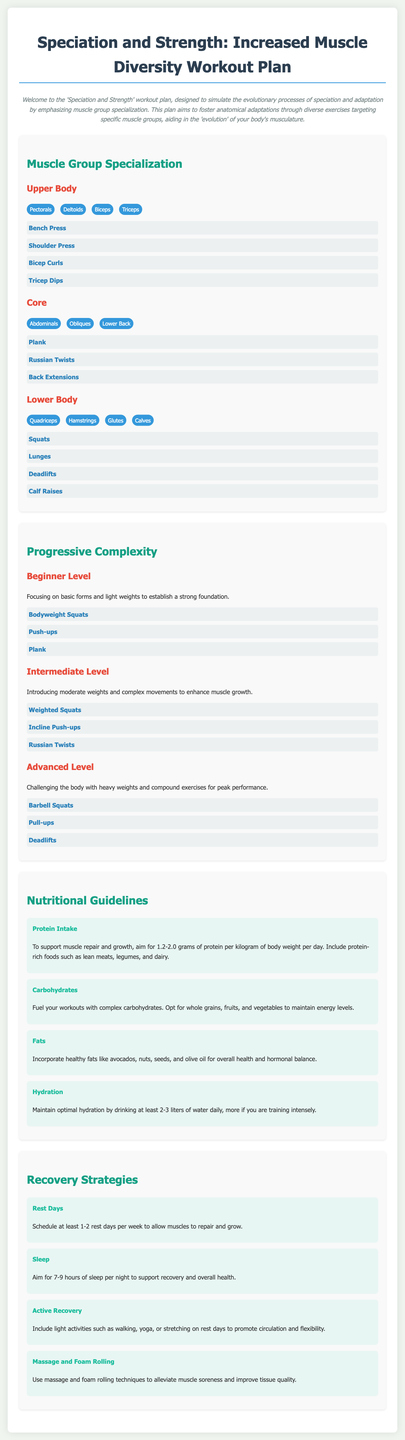what is the title of the workout plan? The title of the workout plan is found within the header of the document.
Answer: Speciation and Strength: Increased Muscle Diversity Workout Plan how many muscle groups are emphasized in the upper body section? The upper body section lists four specific muscle groups.
Answer: 4 name one exercise listed under the Core muscle group. The exercises for the Core muscle group are specified in a bullet list.
Answer: Plank what level of workout is recommended for establishing a strong foundation? The level of workout suitable for developing basic strength is categorized in the document.
Answer: Beginner Level how many grams of protein should one aim to consume per kilogram of body weight? The nutritional guidelines specify a range for protein intake, particularly for muscle repair.
Answer: 1.2-2.0 grams how many rest days are recommended per week? The recommendation for weekly rest days is highlighted in the recovery strategies section.
Answer: 1-2 which exercise is listed under the Intermediate Level? The intermediate level includes complex movements and is categorized in a list.
Answer: Russian Twists what type of fat is suggested for incorporation into the diet? The nutritional guidelines provide examples of healthy fats to include in meals.
Answer: Avocados, nuts, seeds, and olive oil 